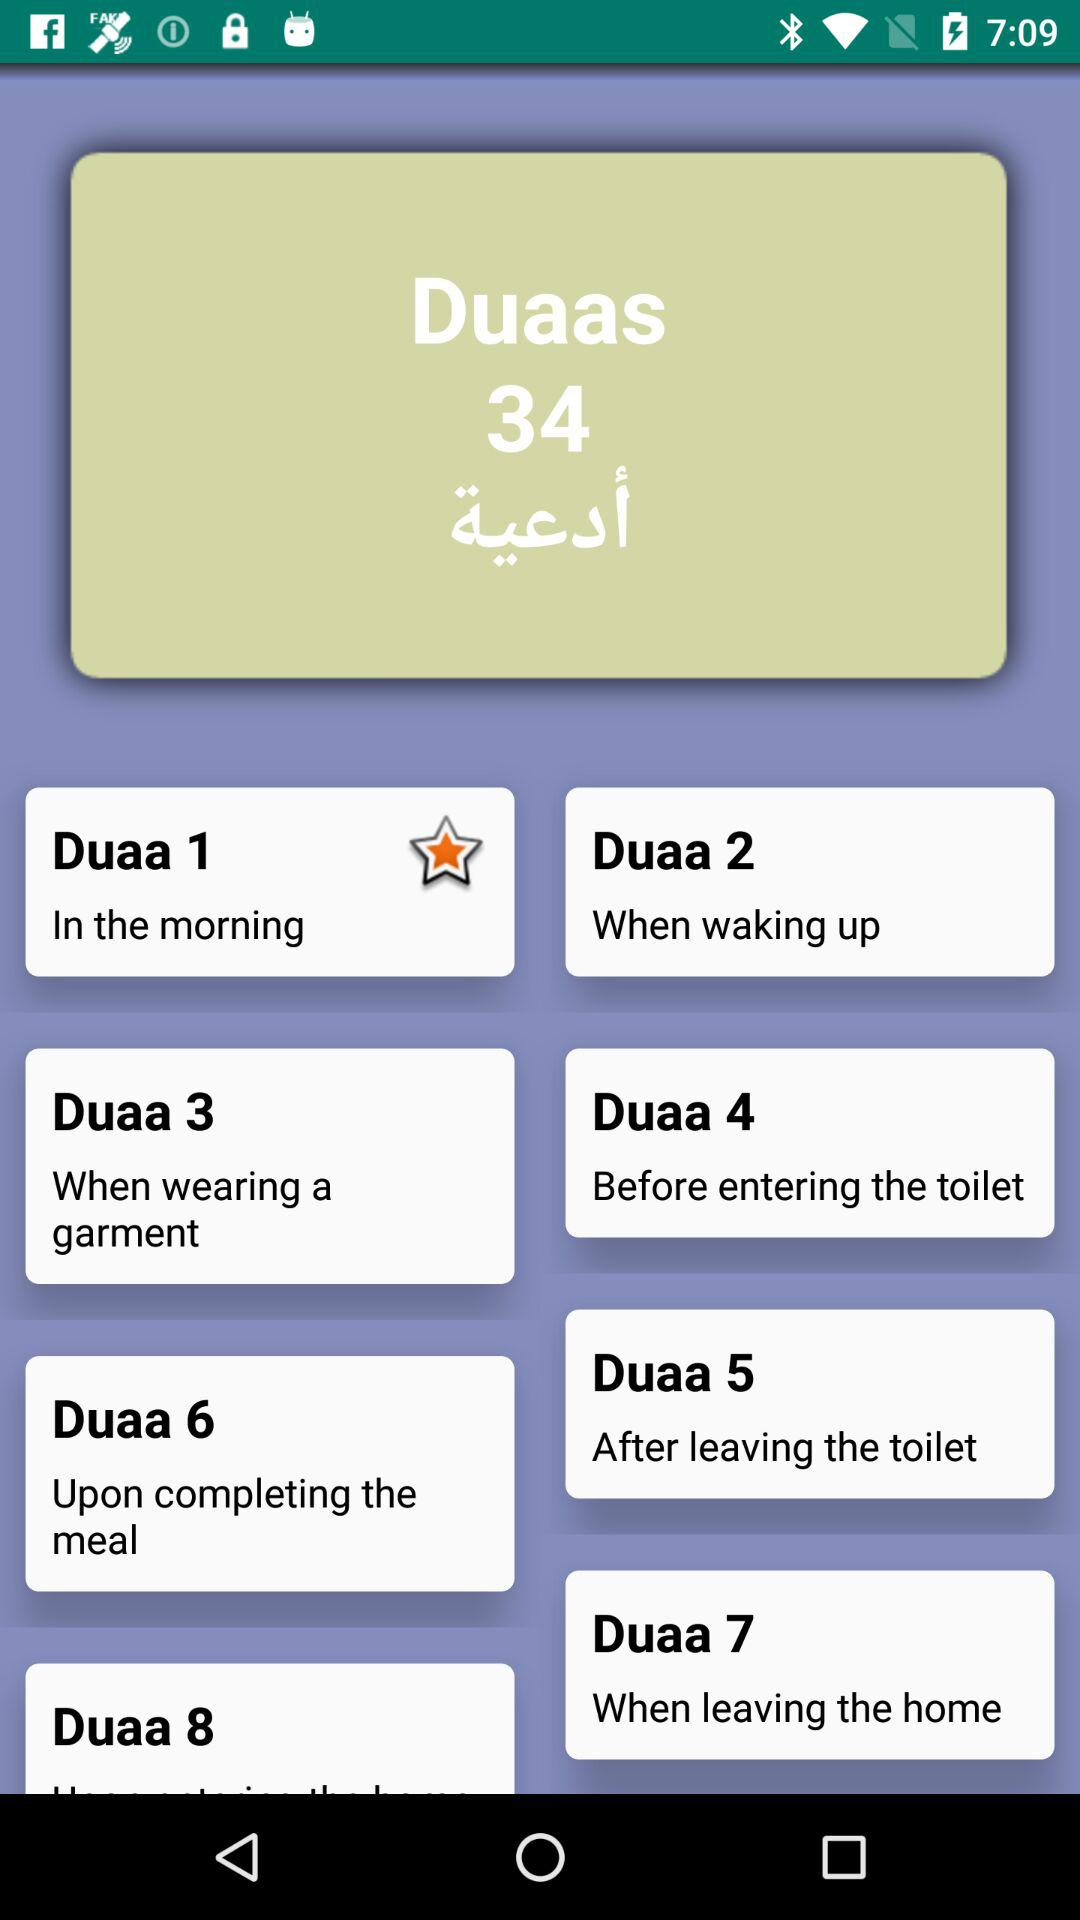When should "Duaa 4" be done? "Duaa 4" should be done before entering the toilet. 